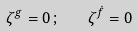<formula> <loc_0><loc_0><loc_500><loc_500>\zeta ^ { g } = 0 \, ; \quad \zeta ^ { \dot { f } } = 0</formula> 